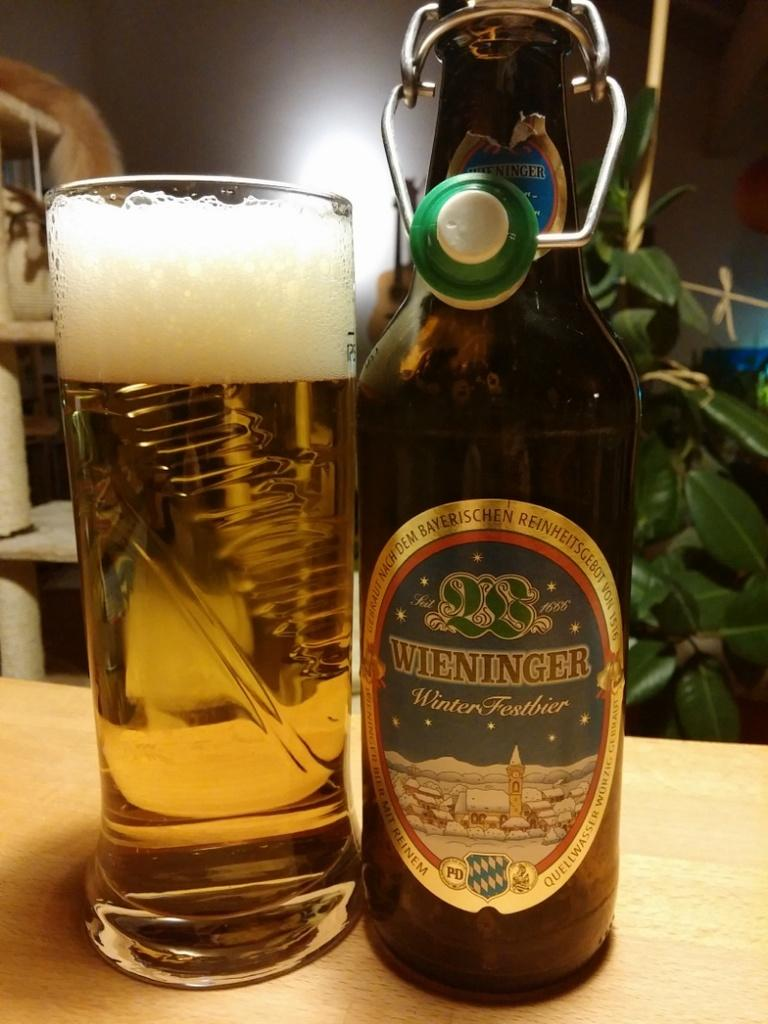<image>
Share a concise interpretation of the image provided. Bottle of Wieninger beer next to a tall cup of beer. 